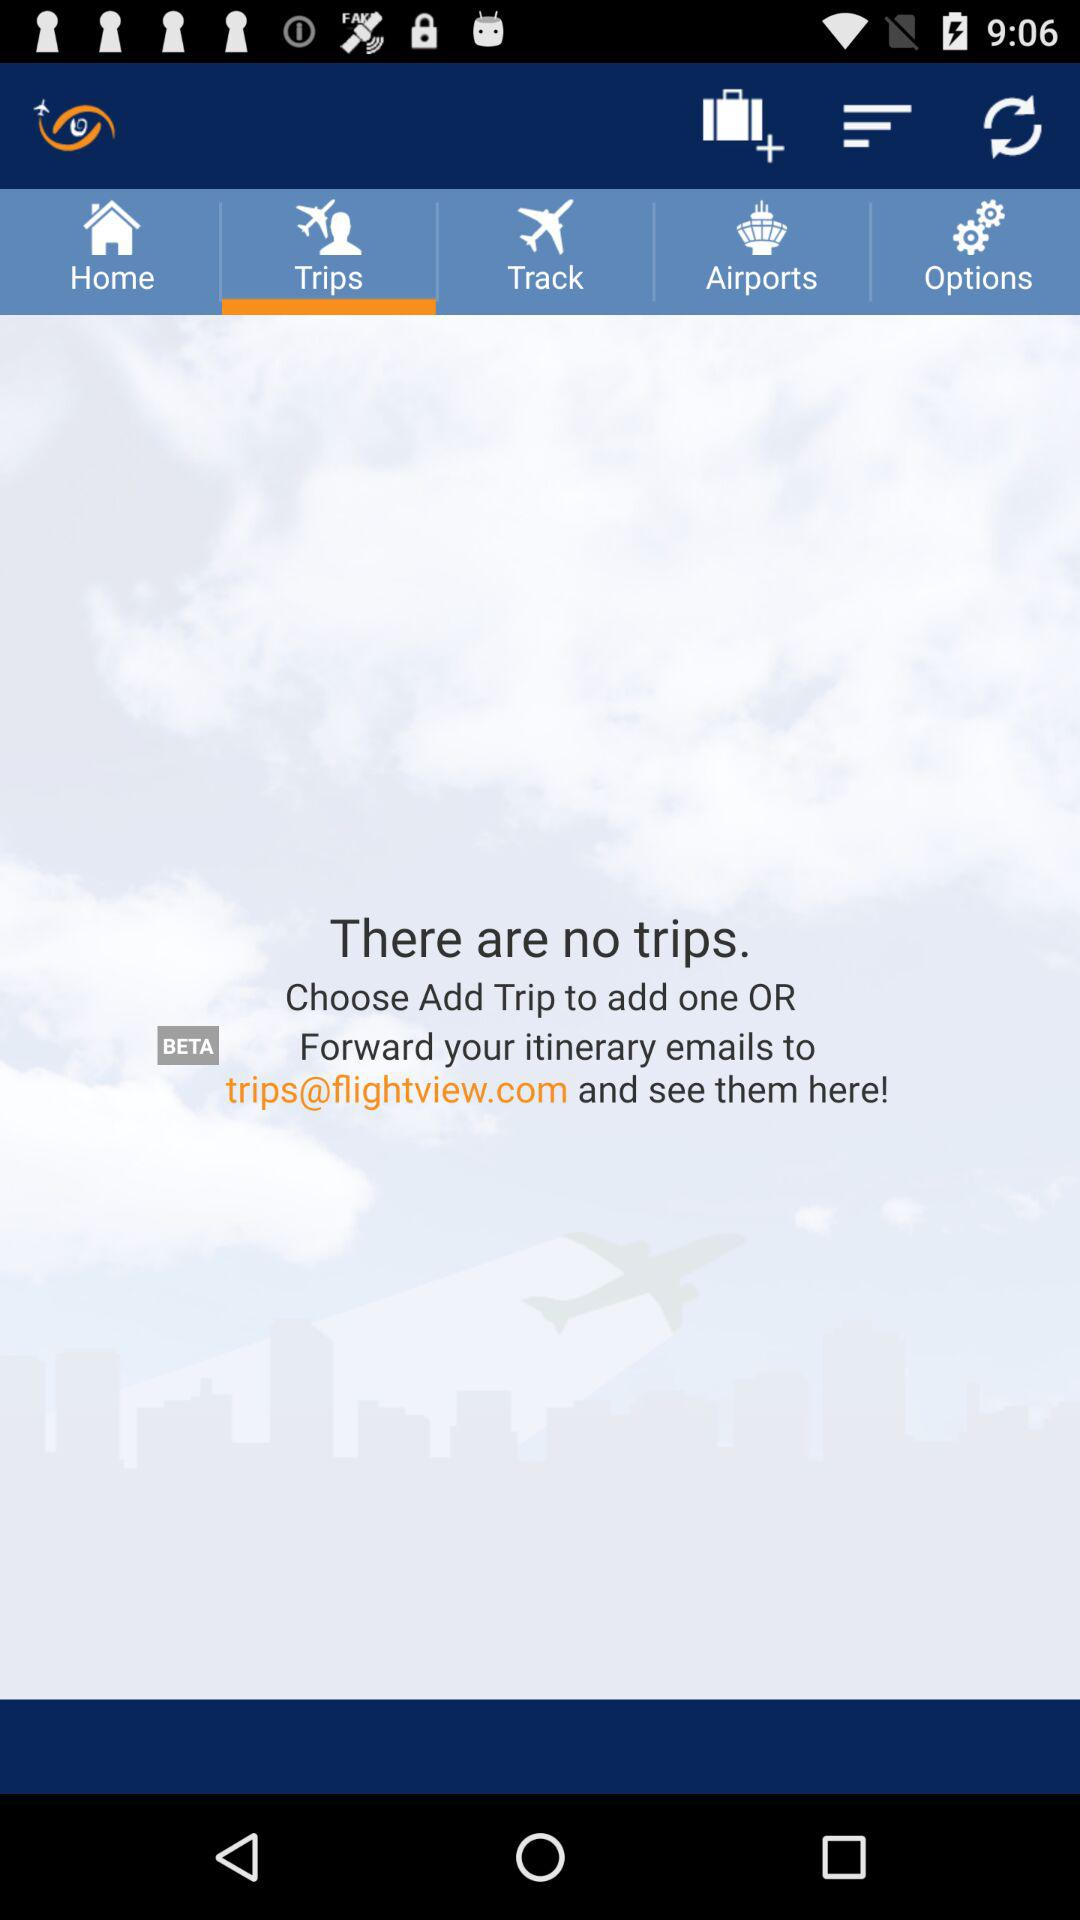What is the email address for forwarding itinerary emails? The email address for forwarding itinerary emails is trips@flightview.com. 